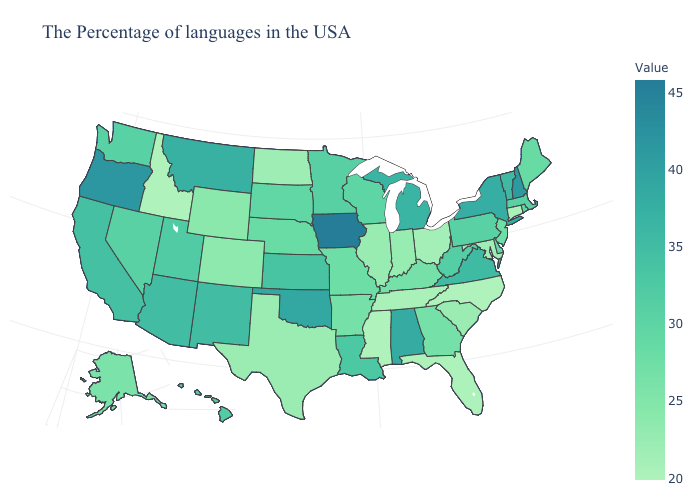Which states have the lowest value in the USA?
Keep it brief. North Carolina, Mississippi, Idaho. Does Ohio have the highest value in the MidWest?
Keep it brief. No. Which states have the lowest value in the Northeast?
Answer briefly. Connecticut. 